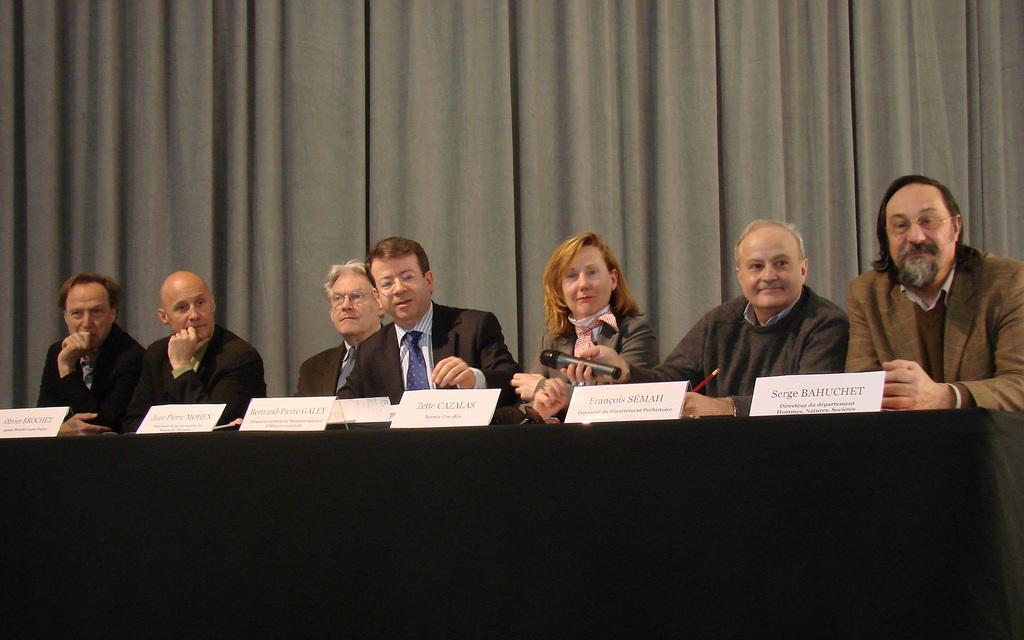What type of event is taking place in the image? The image is taken at a conference. Where are the people located in the image? The people are in the center of the image. What is in the center of the image with the people? There is a table in the center of the image. What can be used to identify the people in the image? Name plates are present in the image. What else can be seen in the image besides the people and table? There are other objects in the image. What can be seen in the background of the image? Curtains are visible in the background of the image. Can you see a flock of birds flying in the image? There is no flock of birds visible in the image. What type of fork is being used by the people in the image? There are no forks present in the image. 